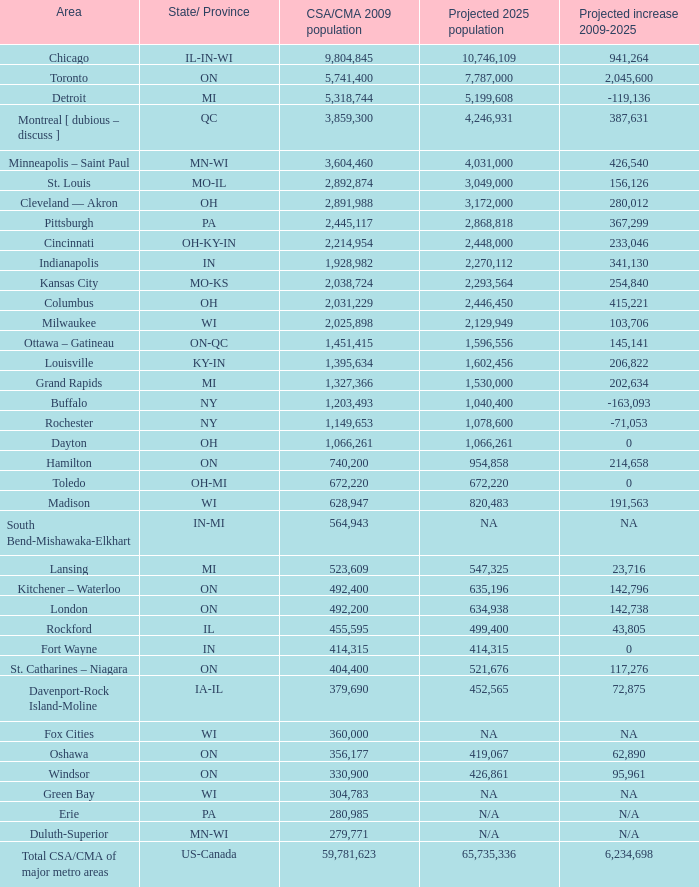What's the projected population of IN-MI? NA. 